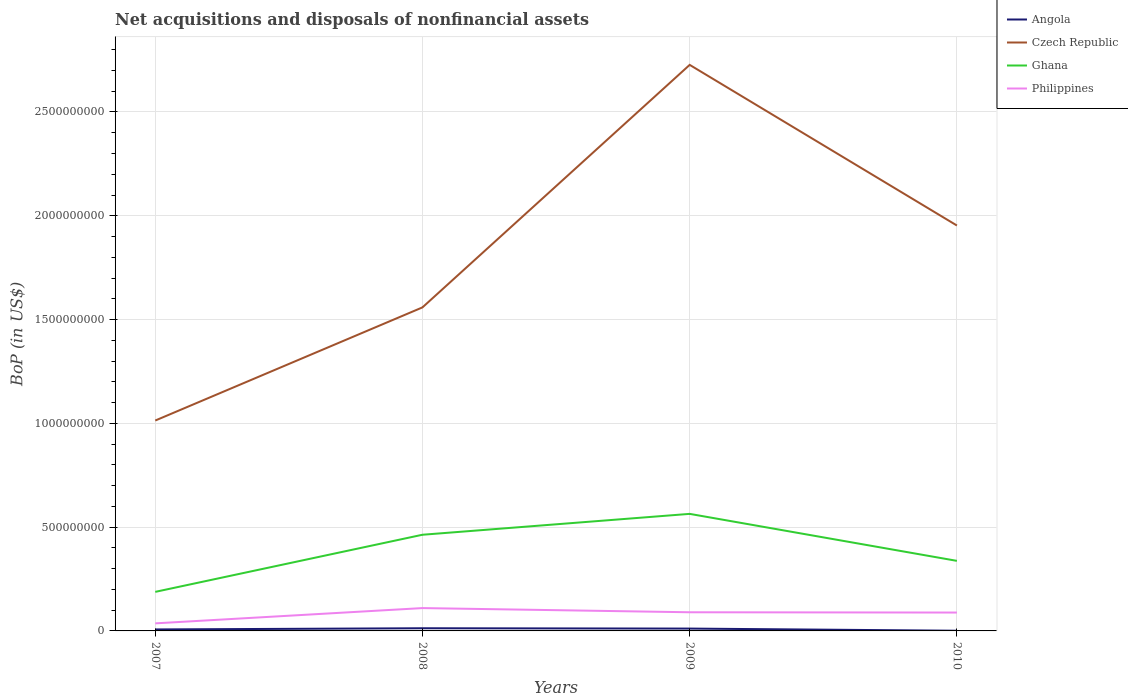How many different coloured lines are there?
Offer a terse response. 4. Does the line corresponding to Czech Republic intersect with the line corresponding to Ghana?
Ensure brevity in your answer.  No. Is the number of lines equal to the number of legend labels?
Provide a short and direct response. Yes. Across all years, what is the maximum Balance of Payments in Czech Republic?
Keep it short and to the point. 1.01e+09. In which year was the Balance of Payments in Czech Republic maximum?
Provide a succinct answer. 2007. What is the total Balance of Payments in Czech Republic in the graph?
Ensure brevity in your answer.  7.74e+08. What is the difference between the highest and the second highest Balance of Payments in Czech Republic?
Provide a short and direct response. 1.71e+09. How many lines are there?
Your answer should be compact. 4. What is the difference between two consecutive major ticks on the Y-axis?
Offer a very short reply. 5.00e+08. Does the graph contain any zero values?
Your answer should be very brief. No. Does the graph contain grids?
Provide a short and direct response. Yes. How many legend labels are there?
Provide a succinct answer. 4. How are the legend labels stacked?
Provide a short and direct response. Vertical. What is the title of the graph?
Give a very brief answer. Net acquisitions and disposals of nonfinancial assets. Does "Venezuela" appear as one of the legend labels in the graph?
Provide a short and direct response. No. What is the label or title of the X-axis?
Ensure brevity in your answer.  Years. What is the label or title of the Y-axis?
Offer a terse response. BoP (in US$). What is the BoP (in US$) of Angola in 2007?
Your answer should be compact. 7.17e+06. What is the BoP (in US$) of Czech Republic in 2007?
Give a very brief answer. 1.01e+09. What is the BoP (in US$) in Ghana in 2007?
Ensure brevity in your answer.  1.88e+08. What is the BoP (in US$) in Philippines in 2007?
Keep it short and to the point. 3.64e+07. What is the BoP (in US$) of Angola in 2008?
Your response must be concise. 1.29e+07. What is the BoP (in US$) in Czech Republic in 2008?
Offer a terse response. 1.56e+09. What is the BoP (in US$) in Ghana in 2008?
Keep it short and to the point. 4.63e+08. What is the BoP (in US$) of Philippines in 2008?
Offer a very short reply. 1.10e+08. What is the BoP (in US$) of Angola in 2009?
Provide a succinct answer. 1.13e+07. What is the BoP (in US$) in Czech Republic in 2009?
Ensure brevity in your answer.  2.73e+09. What is the BoP (in US$) of Ghana in 2009?
Offer a very short reply. 5.64e+08. What is the BoP (in US$) in Philippines in 2009?
Ensure brevity in your answer.  8.99e+07. What is the BoP (in US$) in Angola in 2010?
Your answer should be very brief. 9.34e+05. What is the BoP (in US$) of Czech Republic in 2010?
Provide a succinct answer. 1.95e+09. What is the BoP (in US$) of Ghana in 2010?
Give a very brief answer. 3.38e+08. What is the BoP (in US$) in Philippines in 2010?
Give a very brief answer. 8.85e+07. Across all years, what is the maximum BoP (in US$) of Angola?
Offer a very short reply. 1.29e+07. Across all years, what is the maximum BoP (in US$) in Czech Republic?
Provide a succinct answer. 2.73e+09. Across all years, what is the maximum BoP (in US$) of Ghana?
Keep it short and to the point. 5.64e+08. Across all years, what is the maximum BoP (in US$) of Philippines?
Your response must be concise. 1.10e+08. Across all years, what is the minimum BoP (in US$) in Angola?
Ensure brevity in your answer.  9.34e+05. Across all years, what is the minimum BoP (in US$) in Czech Republic?
Your response must be concise. 1.01e+09. Across all years, what is the minimum BoP (in US$) in Ghana?
Ensure brevity in your answer.  1.88e+08. Across all years, what is the minimum BoP (in US$) of Philippines?
Ensure brevity in your answer.  3.64e+07. What is the total BoP (in US$) of Angola in the graph?
Keep it short and to the point. 3.23e+07. What is the total BoP (in US$) in Czech Republic in the graph?
Offer a terse response. 7.25e+09. What is the total BoP (in US$) of Ghana in the graph?
Offer a very short reply. 1.55e+09. What is the total BoP (in US$) of Philippines in the graph?
Provide a short and direct response. 3.25e+08. What is the difference between the BoP (in US$) of Angola in 2007 and that in 2008?
Offer a very short reply. -5.72e+06. What is the difference between the BoP (in US$) of Czech Republic in 2007 and that in 2008?
Your answer should be compact. -5.45e+08. What is the difference between the BoP (in US$) in Ghana in 2007 and that in 2008?
Provide a short and direct response. -2.75e+08. What is the difference between the BoP (in US$) in Philippines in 2007 and that in 2008?
Give a very brief answer. -7.36e+07. What is the difference between the BoP (in US$) of Angola in 2007 and that in 2009?
Keep it short and to the point. -4.08e+06. What is the difference between the BoP (in US$) in Czech Republic in 2007 and that in 2009?
Offer a terse response. -1.71e+09. What is the difference between the BoP (in US$) of Ghana in 2007 and that in 2009?
Your answer should be compact. -3.76e+08. What is the difference between the BoP (in US$) of Philippines in 2007 and that in 2009?
Your answer should be very brief. -5.34e+07. What is the difference between the BoP (in US$) of Angola in 2007 and that in 2010?
Provide a short and direct response. 6.24e+06. What is the difference between the BoP (in US$) of Czech Republic in 2007 and that in 2010?
Ensure brevity in your answer.  -9.40e+08. What is the difference between the BoP (in US$) in Ghana in 2007 and that in 2010?
Give a very brief answer. -1.49e+08. What is the difference between the BoP (in US$) in Philippines in 2007 and that in 2010?
Offer a very short reply. -5.21e+07. What is the difference between the BoP (in US$) of Angola in 2008 and that in 2009?
Ensure brevity in your answer.  1.64e+06. What is the difference between the BoP (in US$) of Czech Republic in 2008 and that in 2009?
Offer a very short reply. -1.17e+09. What is the difference between the BoP (in US$) in Ghana in 2008 and that in 2009?
Offer a terse response. -1.01e+08. What is the difference between the BoP (in US$) in Philippines in 2008 and that in 2009?
Provide a short and direct response. 2.02e+07. What is the difference between the BoP (in US$) of Angola in 2008 and that in 2010?
Make the answer very short. 1.20e+07. What is the difference between the BoP (in US$) of Czech Republic in 2008 and that in 2010?
Give a very brief answer. -3.94e+08. What is the difference between the BoP (in US$) in Ghana in 2008 and that in 2010?
Offer a terse response. 1.26e+08. What is the difference between the BoP (in US$) in Philippines in 2008 and that in 2010?
Offer a very short reply. 2.16e+07. What is the difference between the BoP (in US$) of Angola in 2009 and that in 2010?
Make the answer very short. 1.03e+07. What is the difference between the BoP (in US$) of Czech Republic in 2009 and that in 2010?
Give a very brief answer. 7.74e+08. What is the difference between the BoP (in US$) of Ghana in 2009 and that in 2010?
Offer a very short reply. 2.26e+08. What is the difference between the BoP (in US$) of Philippines in 2009 and that in 2010?
Make the answer very short. 1.39e+06. What is the difference between the BoP (in US$) in Angola in 2007 and the BoP (in US$) in Czech Republic in 2008?
Ensure brevity in your answer.  -1.55e+09. What is the difference between the BoP (in US$) of Angola in 2007 and the BoP (in US$) of Ghana in 2008?
Your answer should be very brief. -4.56e+08. What is the difference between the BoP (in US$) of Angola in 2007 and the BoP (in US$) of Philippines in 2008?
Give a very brief answer. -1.03e+08. What is the difference between the BoP (in US$) in Czech Republic in 2007 and the BoP (in US$) in Ghana in 2008?
Keep it short and to the point. 5.50e+08. What is the difference between the BoP (in US$) of Czech Republic in 2007 and the BoP (in US$) of Philippines in 2008?
Give a very brief answer. 9.03e+08. What is the difference between the BoP (in US$) of Ghana in 2007 and the BoP (in US$) of Philippines in 2008?
Keep it short and to the point. 7.81e+07. What is the difference between the BoP (in US$) of Angola in 2007 and the BoP (in US$) of Czech Republic in 2009?
Provide a succinct answer. -2.72e+09. What is the difference between the BoP (in US$) in Angola in 2007 and the BoP (in US$) in Ghana in 2009?
Your answer should be very brief. -5.57e+08. What is the difference between the BoP (in US$) in Angola in 2007 and the BoP (in US$) in Philippines in 2009?
Offer a terse response. -8.27e+07. What is the difference between the BoP (in US$) of Czech Republic in 2007 and the BoP (in US$) of Ghana in 2009?
Offer a very short reply. 4.50e+08. What is the difference between the BoP (in US$) of Czech Republic in 2007 and the BoP (in US$) of Philippines in 2009?
Provide a short and direct response. 9.24e+08. What is the difference between the BoP (in US$) of Ghana in 2007 and the BoP (in US$) of Philippines in 2009?
Your answer should be compact. 9.83e+07. What is the difference between the BoP (in US$) of Angola in 2007 and the BoP (in US$) of Czech Republic in 2010?
Your response must be concise. -1.95e+09. What is the difference between the BoP (in US$) of Angola in 2007 and the BoP (in US$) of Ghana in 2010?
Your answer should be compact. -3.30e+08. What is the difference between the BoP (in US$) in Angola in 2007 and the BoP (in US$) in Philippines in 2010?
Your response must be concise. -8.13e+07. What is the difference between the BoP (in US$) of Czech Republic in 2007 and the BoP (in US$) of Ghana in 2010?
Keep it short and to the point. 6.76e+08. What is the difference between the BoP (in US$) in Czech Republic in 2007 and the BoP (in US$) in Philippines in 2010?
Your answer should be compact. 9.25e+08. What is the difference between the BoP (in US$) of Ghana in 2007 and the BoP (in US$) of Philippines in 2010?
Make the answer very short. 9.96e+07. What is the difference between the BoP (in US$) in Angola in 2008 and the BoP (in US$) in Czech Republic in 2009?
Make the answer very short. -2.71e+09. What is the difference between the BoP (in US$) of Angola in 2008 and the BoP (in US$) of Ghana in 2009?
Provide a succinct answer. -5.51e+08. What is the difference between the BoP (in US$) of Angola in 2008 and the BoP (in US$) of Philippines in 2009?
Your answer should be compact. -7.70e+07. What is the difference between the BoP (in US$) in Czech Republic in 2008 and the BoP (in US$) in Ghana in 2009?
Ensure brevity in your answer.  9.95e+08. What is the difference between the BoP (in US$) of Czech Republic in 2008 and the BoP (in US$) of Philippines in 2009?
Keep it short and to the point. 1.47e+09. What is the difference between the BoP (in US$) of Ghana in 2008 and the BoP (in US$) of Philippines in 2009?
Your answer should be compact. 3.73e+08. What is the difference between the BoP (in US$) of Angola in 2008 and the BoP (in US$) of Czech Republic in 2010?
Offer a very short reply. -1.94e+09. What is the difference between the BoP (in US$) of Angola in 2008 and the BoP (in US$) of Ghana in 2010?
Make the answer very short. -3.25e+08. What is the difference between the BoP (in US$) of Angola in 2008 and the BoP (in US$) of Philippines in 2010?
Your response must be concise. -7.56e+07. What is the difference between the BoP (in US$) in Czech Republic in 2008 and the BoP (in US$) in Ghana in 2010?
Provide a succinct answer. 1.22e+09. What is the difference between the BoP (in US$) of Czech Republic in 2008 and the BoP (in US$) of Philippines in 2010?
Ensure brevity in your answer.  1.47e+09. What is the difference between the BoP (in US$) in Ghana in 2008 and the BoP (in US$) in Philippines in 2010?
Your response must be concise. 3.75e+08. What is the difference between the BoP (in US$) of Angola in 2009 and the BoP (in US$) of Czech Republic in 2010?
Give a very brief answer. -1.94e+09. What is the difference between the BoP (in US$) of Angola in 2009 and the BoP (in US$) of Ghana in 2010?
Offer a very short reply. -3.26e+08. What is the difference between the BoP (in US$) in Angola in 2009 and the BoP (in US$) in Philippines in 2010?
Offer a terse response. -7.72e+07. What is the difference between the BoP (in US$) of Czech Republic in 2009 and the BoP (in US$) of Ghana in 2010?
Provide a short and direct response. 2.39e+09. What is the difference between the BoP (in US$) in Czech Republic in 2009 and the BoP (in US$) in Philippines in 2010?
Your response must be concise. 2.64e+09. What is the difference between the BoP (in US$) of Ghana in 2009 and the BoP (in US$) of Philippines in 2010?
Provide a succinct answer. 4.75e+08. What is the average BoP (in US$) of Angola per year?
Your response must be concise. 8.07e+06. What is the average BoP (in US$) in Czech Republic per year?
Give a very brief answer. 1.81e+09. What is the average BoP (in US$) of Ghana per year?
Your answer should be compact. 3.88e+08. What is the average BoP (in US$) of Philippines per year?
Keep it short and to the point. 8.12e+07. In the year 2007, what is the difference between the BoP (in US$) in Angola and BoP (in US$) in Czech Republic?
Offer a very short reply. -1.01e+09. In the year 2007, what is the difference between the BoP (in US$) in Angola and BoP (in US$) in Ghana?
Your response must be concise. -1.81e+08. In the year 2007, what is the difference between the BoP (in US$) in Angola and BoP (in US$) in Philippines?
Offer a terse response. -2.93e+07. In the year 2007, what is the difference between the BoP (in US$) of Czech Republic and BoP (in US$) of Ghana?
Provide a succinct answer. 8.25e+08. In the year 2007, what is the difference between the BoP (in US$) in Czech Republic and BoP (in US$) in Philippines?
Provide a succinct answer. 9.77e+08. In the year 2007, what is the difference between the BoP (in US$) of Ghana and BoP (in US$) of Philippines?
Provide a succinct answer. 1.52e+08. In the year 2008, what is the difference between the BoP (in US$) in Angola and BoP (in US$) in Czech Republic?
Provide a short and direct response. -1.55e+09. In the year 2008, what is the difference between the BoP (in US$) in Angola and BoP (in US$) in Ghana?
Your answer should be compact. -4.50e+08. In the year 2008, what is the difference between the BoP (in US$) in Angola and BoP (in US$) in Philippines?
Keep it short and to the point. -9.72e+07. In the year 2008, what is the difference between the BoP (in US$) of Czech Republic and BoP (in US$) of Ghana?
Your response must be concise. 1.10e+09. In the year 2008, what is the difference between the BoP (in US$) in Czech Republic and BoP (in US$) in Philippines?
Provide a succinct answer. 1.45e+09. In the year 2008, what is the difference between the BoP (in US$) in Ghana and BoP (in US$) in Philippines?
Offer a very short reply. 3.53e+08. In the year 2009, what is the difference between the BoP (in US$) in Angola and BoP (in US$) in Czech Republic?
Your response must be concise. -2.72e+09. In the year 2009, what is the difference between the BoP (in US$) in Angola and BoP (in US$) in Ghana?
Make the answer very short. -5.53e+08. In the year 2009, what is the difference between the BoP (in US$) of Angola and BoP (in US$) of Philippines?
Make the answer very short. -7.86e+07. In the year 2009, what is the difference between the BoP (in US$) of Czech Republic and BoP (in US$) of Ghana?
Keep it short and to the point. 2.16e+09. In the year 2009, what is the difference between the BoP (in US$) of Czech Republic and BoP (in US$) of Philippines?
Provide a short and direct response. 2.64e+09. In the year 2009, what is the difference between the BoP (in US$) of Ghana and BoP (in US$) of Philippines?
Your answer should be very brief. 4.74e+08. In the year 2010, what is the difference between the BoP (in US$) in Angola and BoP (in US$) in Czech Republic?
Keep it short and to the point. -1.95e+09. In the year 2010, what is the difference between the BoP (in US$) of Angola and BoP (in US$) of Ghana?
Make the answer very short. -3.37e+08. In the year 2010, what is the difference between the BoP (in US$) in Angola and BoP (in US$) in Philippines?
Your answer should be compact. -8.76e+07. In the year 2010, what is the difference between the BoP (in US$) in Czech Republic and BoP (in US$) in Ghana?
Ensure brevity in your answer.  1.62e+09. In the year 2010, what is the difference between the BoP (in US$) in Czech Republic and BoP (in US$) in Philippines?
Provide a succinct answer. 1.86e+09. In the year 2010, what is the difference between the BoP (in US$) in Ghana and BoP (in US$) in Philippines?
Ensure brevity in your answer.  2.49e+08. What is the ratio of the BoP (in US$) of Angola in 2007 to that in 2008?
Offer a terse response. 0.56. What is the ratio of the BoP (in US$) of Czech Republic in 2007 to that in 2008?
Your answer should be very brief. 0.65. What is the ratio of the BoP (in US$) in Ghana in 2007 to that in 2008?
Keep it short and to the point. 0.41. What is the ratio of the BoP (in US$) of Philippines in 2007 to that in 2008?
Provide a succinct answer. 0.33. What is the ratio of the BoP (in US$) in Angola in 2007 to that in 2009?
Offer a terse response. 0.64. What is the ratio of the BoP (in US$) of Czech Republic in 2007 to that in 2009?
Provide a succinct answer. 0.37. What is the ratio of the BoP (in US$) in Ghana in 2007 to that in 2009?
Your response must be concise. 0.33. What is the ratio of the BoP (in US$) of Philippines in 2007 to that in 2009?
Provide a short and direct response. 0.41. What is the ratio of the BoP (in US$) of Angola in 2007 to that in 2010?
Offer a very short reply. 7.68. What is the ratio of the BoP (in US$) in Czech Republic in 2007 to that in 2010?
Keep it short and to the point. 0.52. What is the ratio of the BoP (in US$) of Ghana in 2007 to that in 2010?
Your answer should be compact. 0.56. What is the ratio of the BoP (in US$) in Philippines in 2007 to that in 2010?
Offer a very short reply. 0.41. What is the ratio of the BoP (in US$) of Angola in 2008 to that in 2009?
Your answer should be compact. 1.15. What is the ratio of the BoP (in US$) of Czech Republic in 2008 to that in 2009?
Make the answer very short. 0.57. What is the ratio of the BoP (in US$) in Ghana in 2008 to that in 2009?
Your answer should be very brief. 0.82. What is the ratio of the BoP (in US$) in Philippines in 2008 to that in 2009?
Offer a terse response. 1.22. What is the ratio of the BoP (in US$) in Angola in 2008 to that in 2010?
Make the answer very short. 13.81. What is the ratio of the BoP (in US$) in Czech Republic in 2008 to that in 2010?
Your response must be concise. 0.8. What is the ratio of the BoP (in US$) in Ghana in 2008 to that in 2010?
Give a very brief answer. 1.37. What is the ratio of the BoP (in US$) of Philippines in 2008 to that in 2010?
Provide a succinct answer. 1.24. What is the ratio of the BoP (in US$) in Angola in 2009 to that in 2010?
Your answer should be very brief. 12.05. What is the ratio of the BoP (in US$) of Czech Republic in 2009 to that in 2010?
Make the answer very short. 1.4. What is the ratio of the BoP (in US$) in Ghana in 2009 to that in 2010?
Your answer should be compact. 1.67. What is the ratio of the BoP (in US$) of Philippines in 2009 to that in 2010?
Your response must be concise. 1.02. What is the difference between the highest and the second highest BoP (in US$) in Angola?
Ensure brevity in your answer.  1.64e+06. What is the difference between the highest and the second highest BoP (in US$) of Czech Republic?
Give a very brief answer. 7.74e+08. What is the difference between the highest and the second highest BoP (in US$) in Ghana?
Your answer should be compact. 1.01e+08. What is the difference between the highest and the second highest BoP (in US$) of Philippines?
Ensure brevity in your answer.  2.02e+07. What is the difference between the highest and the lowest BoP (in US$) in Angola?
Provide a short and direct response. 1.20e+07. What is the difference between the highest and the lowest BoP (in US$) of Czech Republic?
Offer a terse response. 1.71e+09. What is the difference between the highest and the lowest BoP (in US$) of Ghana?
Offer a terse response. 3.76e+08. What is the difference between the highest and the lowest BoP (in US$) of Philippines?
Keep it short and to the point. 7.36e+07. 